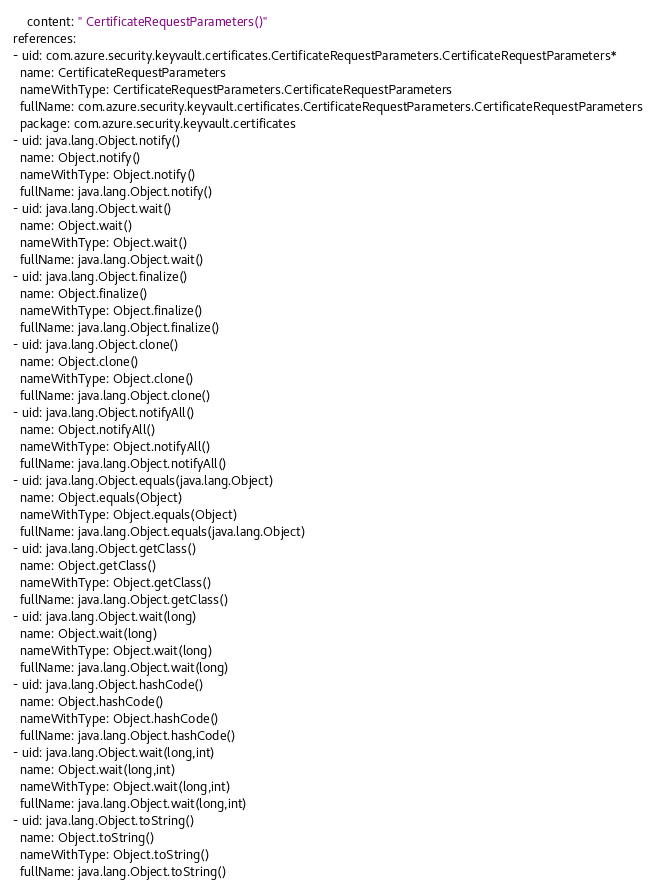Convert code to text. <code><loc_0><loc_0><loc_500><loc_500><_YAML_>    content: " CertificateRequestParameters()"
references:
- uid: com.azure.security.keyvault.certificates.CertificateRequestParameters.CertificateRequestParameters*
  name: CertificateRequestParameters
  nameWithType: CertificateRequestParameters.CertificateRequestParameters
  fullName: com.azure.security.keyvault.certificates.CertificateRequestParameters.CertificateRequestParameters
  package: com.azure.security.keyvault.certificates
- uid: java.lang.Object.notify()
  name: Object.notify()
  nameWithType: Object.notify()
  fullName: java.lang.Object.notify()
- uid: java.lang.Object.wait()
  name: Object.wait()
  nameWithType: Object.wait()
  fullName: java.lang.Object.wait()
- uid: java.lang.Object.finalize()
  name: Object.finalize()
  nameWithType: Object.finalize()
  fullName: java.lang.Object.finalize()
- uid: java.lang.Object.clone()
  name: Object.clone()
  nameWithType: Object.clone()
  fullName: java.lang.Object.clone()
- uid: java.lang.Object.notifyAll()
  name: Object.notifyAll()
  nameWithType: Object.notifyAll()
  fullName: java.lang.Object.notifyAll()
- uid: java.lang.Object.equals(java.lang.Object)
  name: Object.equals(Object)
  nameWithType: Object.equals(Object)
  fullName: java.lang.Object.equals(java.lang.Object)
- uid: java.lang.Object.getClass()
  name: Object.getClass()
  nameWithType: Object.getClass()
  fullName: java.lang.Object.getClass()
- uid: java.lang.Object.wait(long)
  name: Object.wait(long)
  nameWithType: Object.wait(long)
  fullName: java.lang.Object.wait(long)
- uid: java.lang.Object.hashCode()
  name: Object.hashCode()
  nameWithType: Object.hashCode()
  fullName: java.lang.Object.hashCode()
- uid: java.lang.Object.wait(long,int)
  name: Object.wait(long,int)
  nameWithType: Object.wait(long,int)
  fullName: java.lang.Object.wait(long,int)
- uid: java.lang.Object.toString()
  name: Object.toString()
  nameWithType: Object.toString()
  fullName: java.lang.Object.toString()
</code> 